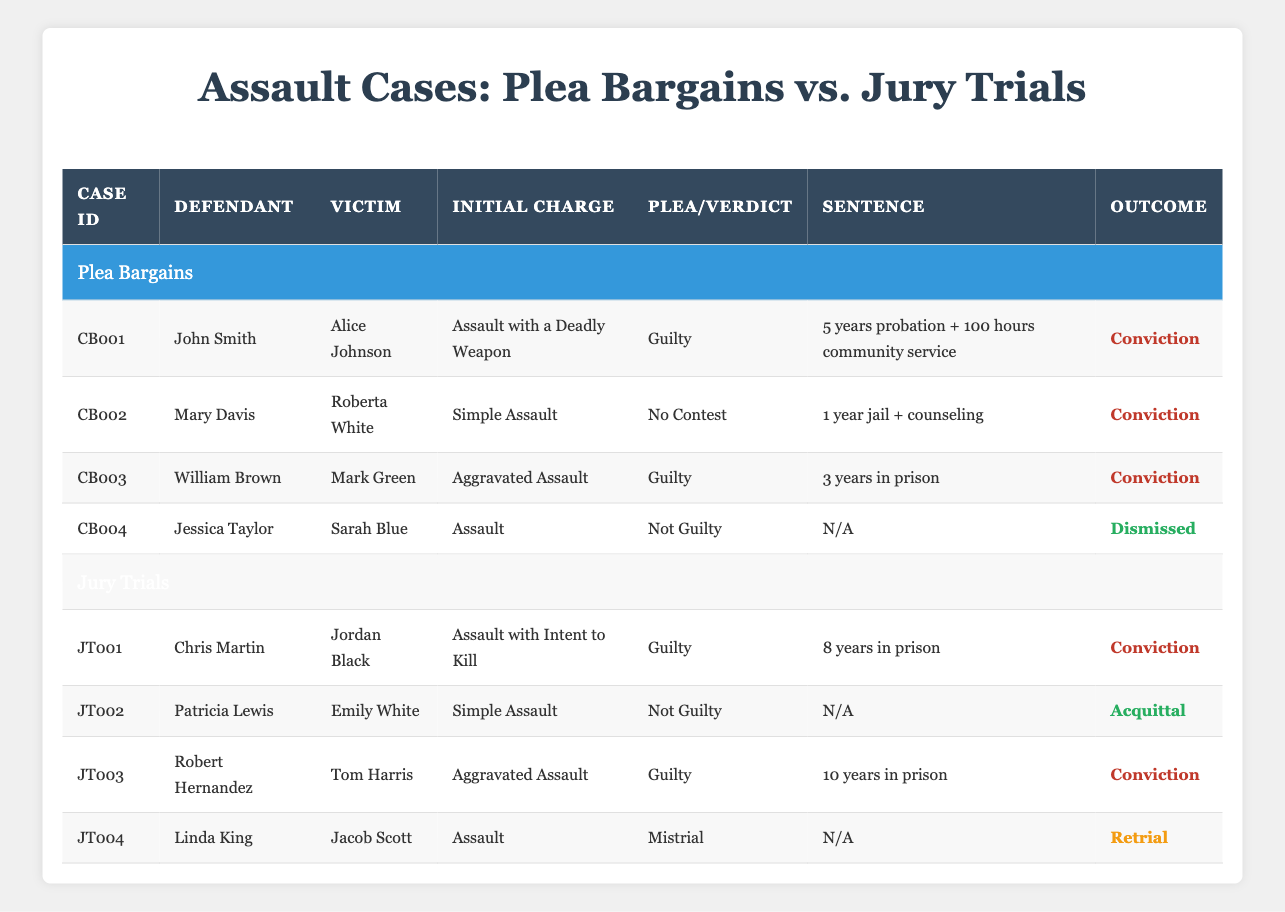What are the initial charges for the plea bargain cases? There are four plea bargain cases listed in the table. The initial charges for each are Assault with a Deadly Weapon, Simple Assault, Aggravated Assault, and Assault.
Answer: Assault with a Deadly Weapon, Simple Assault, Aggravated Assault, Assault How many plea bargain cases resulted in convictions? Out of the four plea bargain cases, three listed outcomes as convictions. Only one case was dismissed.
Answer: Three What was the sentence for the defendant in the case of Chris Martin? Referring to the jury trials section of the table, Chris Martin was found guilty and sentenced to 8 years in prison.
Answer: 8 years in prison Is there any case where a defendant was found Not Guilty in the jury trial? Patricia Lewis was found Not Guilty in her jury trial case, indicating that there was at least one instance where the defendant was acquitted.
Answer: Yes What is the difference in prison time between the longest and shortest sentences in the plea bargains? The longest sentence in the plea bargain cases is 3 years in prison for William Brown, while the shortest is a sentence of 1 year jail for Mary Davis. The difference is 3 years - 1 year = 2 years.
Answer: 2 years How many total cases were tried in front of a jury? There are four jury trial cases listed in the table, which provides the count directly.
Answer: Four Which plea agreement had the least severe consequence? The case of Mary Davis, who received a sentence of 1 year jail plus counseling, had the least severe consequence among plea bargain outcomes.
Answer: 1 year jail + counseling In total, how many outcomes are classified as Conviction across both plea bargains and jury trials? Counting the table data, there are three convictions in plea bargains and three in jury trials, giving a total of 3 + 3 = 6 convictions.
Answer: Six 